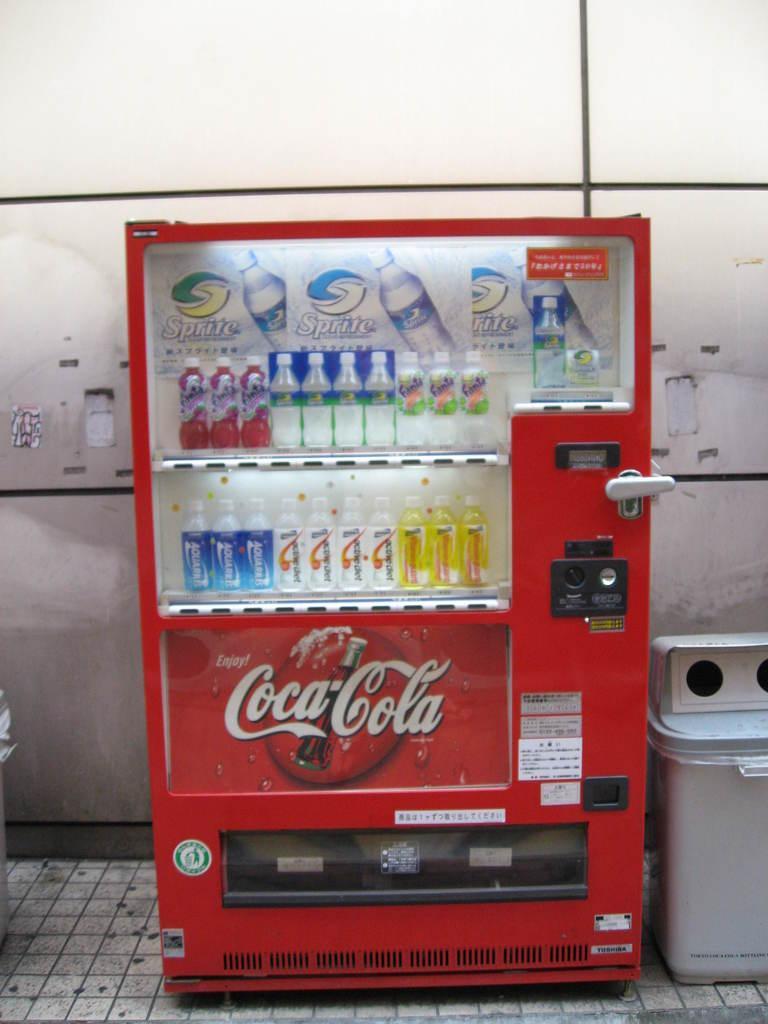In one or two sentences, can you explain what this image depicts? In this image there is a machine in the center which is red in colour with some bottles inside it and there is some text written on the machine. On the right side of the machine there is an object which is white in colour and in the background there is a wall which is white in colour. 